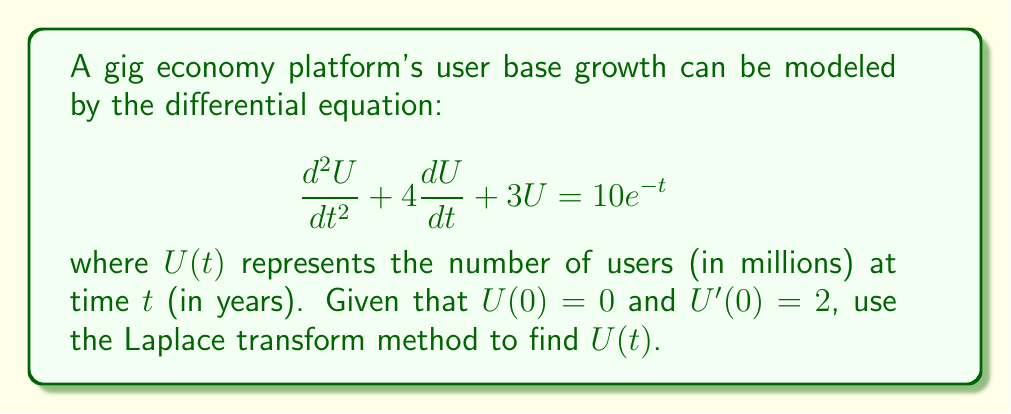Could you help me with this problem? Let's solve this step-by-step using the Laplace transform method:

1) First, we take the Laplace transform of both sides of the equation:

   $\mathcal{L}\{\frac{d^2U}{dt^2} + 4\frac{dU}{dt} + 3U\} = \mathcal{L}\{10e^{-t}\}$

2) Using Laplace transform properties:

   $s^2U(s) - sU(0) - U'(0) + 4[sU(s) - U(0)] + 3U(s) = \frac{10}{s+1}$

3) Substitute the initial conditions $U(0) = 0$ and $U'(0) = 2$:

   $s^2U(s) - 2 + 4sU(s) + 3U(s) = \frac{10}{s+1}$

4) Simplify:

   $(s^2 + 4s + 3)U(s) = \frac{10}{s+1} + 2$

5) Factor the left side:

   $(s + 1)(s + 3)U(s) = \frac{10}{s+1} + 2$

6) Solve for $U(s)$:

   $U(s) = \frac{10}{(s+1)^2(s+3)} + \frac{2}{(s+1)(s+3)}$

7) Use partial fraction decomposition:

   $U(s) = \frac{A}{s+1} + \frac{B}{(s+1)^2} + \frac{C}{s+3}$

   Where:
   $A = -\frac{5}{2}$, $B = 5$, $C = \frac{1}{2}$

8) Take the inverse Laplace transform:

   $U(t) = \mathcal{L}^{-1}\{\frac{-5/2}{s+1} + \frac{5}{(s+1)^2} + \frac{1/2}{s+3}\}$

9) Using inverse Laplace transform properties:

   $U(t) = -\frac{5}{2}e^{-t} + 5te^{-t} + \frac{1}{2}e^{-3t}$
Answer: $U(t) = -\frac{5}{2}e^{-t} + 5te^{-t} + \frac{1}{2}e^{-3t}$ 